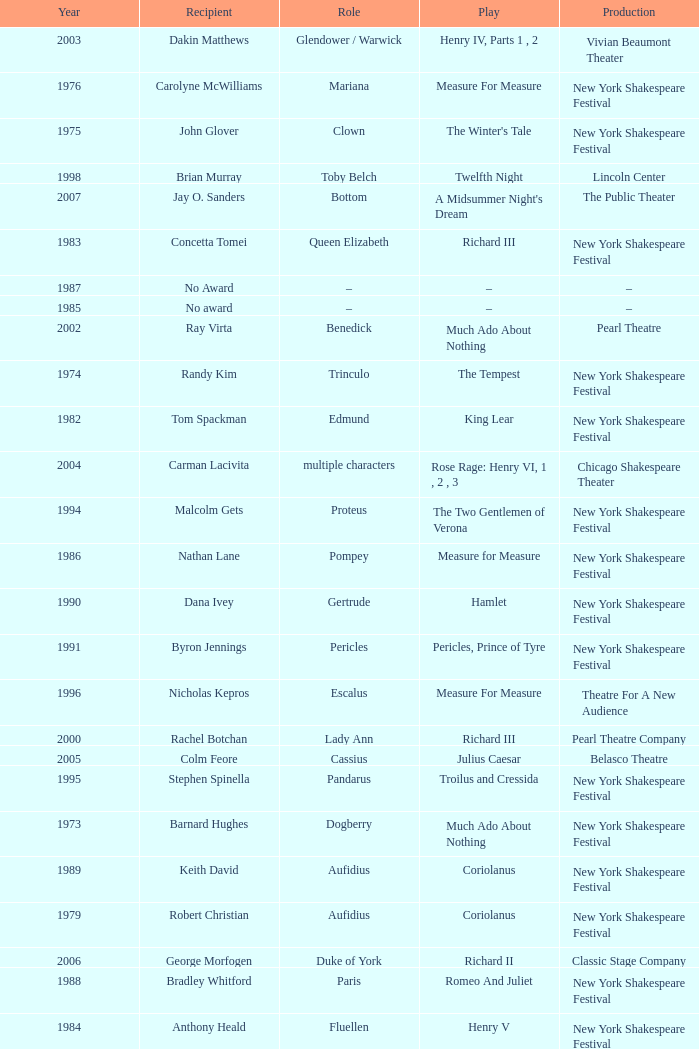Could you parse the entire table? {'header': ['Year', 'Recipient', 'Role', 'Play', 'Production'], 'rows': [['2003', 'Dakin Matthews', 'Glendower / Warwick', 'Henry IV, Parts 1 , 2', 'Vivian Beaumont Theater'], ['1976', 'Carolyne McWilliams', 'Mariana', 'Measure For Measure', 'New York Shakespeare Festival'], ['1975', 'John Glover', 'Clown', "The Winter's Tale", 'New York Shakespeare Festival'], ['1998', 'Brian Murray', 'Toby Belch', 'Twelfth Night', 'Lincoln Center'], ['2007', 'Jay O. Sanders', 'Bottom', "A Midsummer Night's Dream", 'The Public Theater'], ['1983', 'Concetta Tomei', 'Queen Elizabeth', 'Richard III', 'New York Shakespeare Festival'], ['1987', 'No Award', '–', '–', '–'], ['1985', 'No award', '–', '–', '–'], ['2002', 'Ray Virta', 'Benedick', 'Much Ado About Nothing', 'Pearl Theatre'], ['1974', 'Randy Kim', 'Trinculo', 'The Tempest', 'New York Shakespeare Festival'], ['1982', 'Tom Spackman', 'Edmund', 'King Lear', 'New York Shakespeare Festival'], ['2004', 'Carman Lacivita', 'multiple characters', 'Rose Rage: Henry VI, 1 , 2 , 3', 'Chicago Shakespeare Theater'], ['1994', 'Malcolm Gets', 'Proteus', 'The Two Gentlemen of Verona', 'New York Shakespeare Festival'], ['1986', 'Nathan Lane', 'Pompey', 'Measure for Measure', 'New York Shakespeare Festival'], ['1990', 'Dana Ivey', 'Gertrude', 'Hamlet', 'New York Shakespeare Festival'], ['1991', 'Byron Jennings', 'Pericles', 'Pericles, Prince of Tyre', 'New York Shakespeare Festival'], ['1996', 'Nicholas Kepros', 'Escalus', 'Measure For Measure', 'Theatre For A New Audience'], ['2000', 'Rachel Botchan', 'Lady Ann', 'Richard III', 'Pearl Theatre Company'], ['2005', 'Colm Feore', 'Cassius', 'Julius Caesar', 'Belasco Theatre'], ['1995', 'Stephen Spinella', 'Pandarus', 'Troilus and Cressida', 'New York Shakespeare Festival'], ['1973', 'Barnard Hughes', 'Dogberry', 'Much Ado About Nothing', 'New York Shakespeare Festival'], ['1989', 'Keith David', 'Aufidius', 'Coriolanus', 'New York Shakespeare Festival'], ['1979', 'Robert Christian', 'Aufidius', 'Coriolanus', 'New York Shakespeare Festival'], ['2006', 'George Morfogen', 'Duke of York', 'Richard II', 'Classic Stage Company'], ['1988', 'Bradley Whitford', 'Paris', 'Romeo And Juliet', 'New York Shakespeare Festival'], ['1984', 'Anthony Heald', 'Fluellen', 'Henry V', 'New York Shakespeare Festival'], ['1978', 'Carmen DeLavalape', 'Emelia', 'Othello', 'New York Shakespeare Festival'], ['1977', 'No Award', '–', '–', '–'], ['1981', 'Ralph Drischell', 'Earl of Worcester', 'Henry IV', 'New York Shakespeare Festival'], ['1992', 'Elizabeth McGovern', 'Rosalind', 'As You Like It', 'New York Shakespeare Festival'], ['1997', 'Jayne Atkinson', 'Katherine', 'Henry VIII', 'New York Shakespeare Festival'], ['2001', 'Andrew Weems', 'Thersites', 'Troilus and Cressida', 'Theatre For A New Audience'], ['1993', 'Michael Cumpsty', 'Alcibiades', 'Timon of Athens', 'National Theatre'], ['1999', 'Max Wright', 'Christopher Sly', 'The Taming of the Shrew', 'New York Shakespeare Festival'], ['1980', 'No award', '–', '–', '–']]} Name the play for 1976 Measure For Measure. 